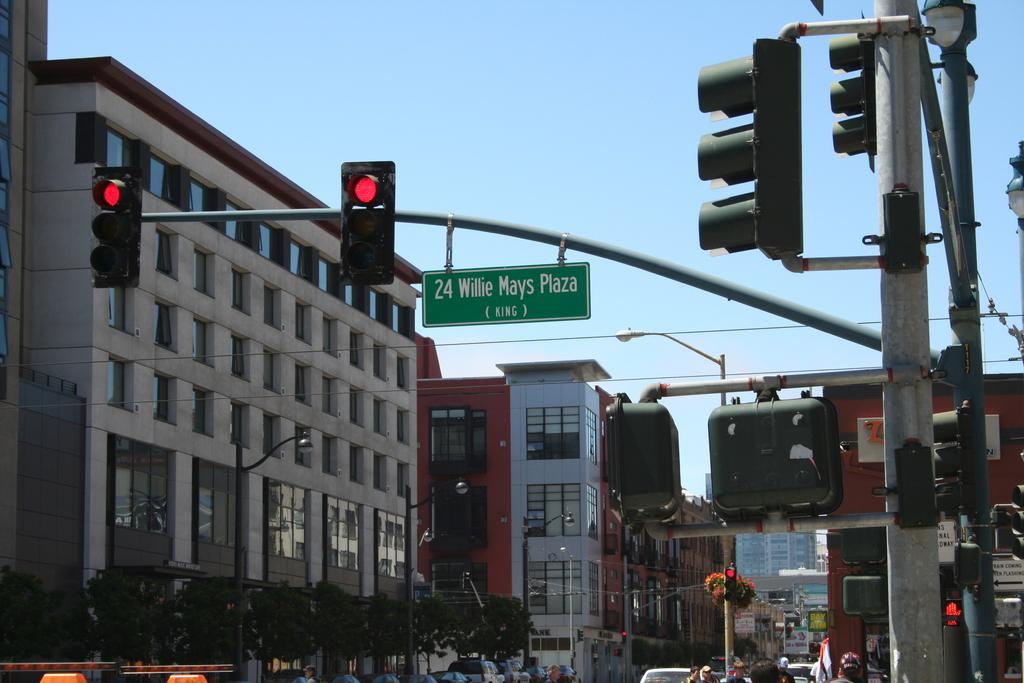<image>
Offer a succinct explanation of the picture presented. the number 24 that is on a street light 